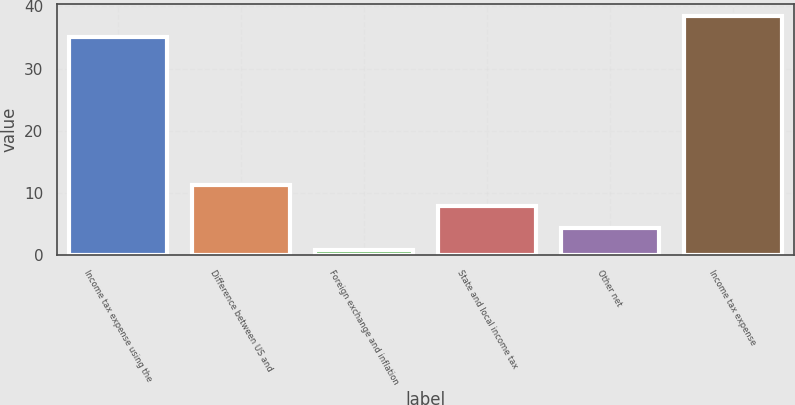<chart> <loc_0><loc_0><loc_500><loc_500><bar_chart><fcel>Income tax expense using the<fcel>Difference between US and<fcel>Foreign exchange and inflation<fcel>State and local income tax<fcel>Other net<fcel>Income tax expense<nl><fcel>35<fcel>11.33<fcel>0.8<fcel>7.82<fcel>4.31<fcel>38.51<nl></chart> 